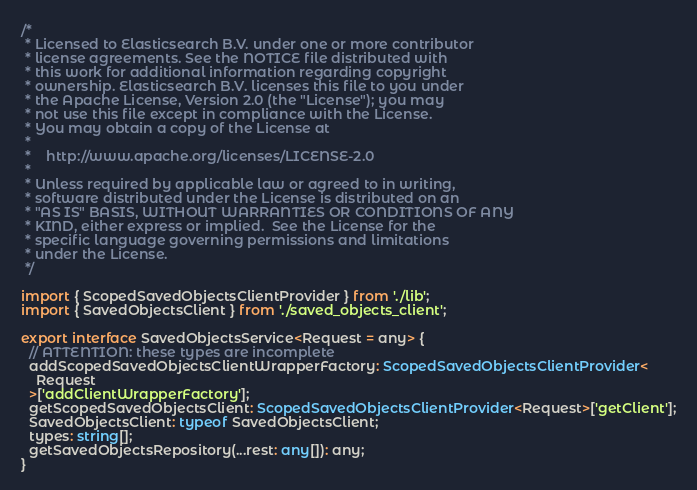Convert code to text. <code><loc_0><loc_0><loc_500><loc_500><_TypeScript_>/*
 * Licensed to Elasticsearch B.V. under one or more contributor
 * license agreements. See the NOTICE file distributed with
 * this work for additional information regarding copyright
 * ownership. Elasticsearch B.V. licenses this file to you under
 * the Apache License, Version 2.0 (the "License"); you may
 * not use this file except in compliance with the License.
 * You may obtain a copy of the License at
 *
 *    http://www.apache.org/licenses/LICENSE-2.0
 *
 * Unless required by applicable law or agreed to in writing,
 * software distributed under the License is distributed on an
 * "AS IS" BASIS, WITHOUT WARRANTIES OR CONDITIONS OF ANY
 * KIND, either express or implied.  See the License for the
 * specific language governing permissions and limitations
 * under the License.
 */

import { ScopedSavedObjectsClientProvider } from './lib';
import { SavedObjectsClient } from './saved_objects_client';

export interface SavedObjectsService<Request = any> {
  // ATTENTION: these types are incomplete
  addScopedSavedObjectsClientWrapperFactory: ScopedSavedObjectsClientProvider<
    Request
  >['addClientWrapperFactory'];
  getScopedSavedObjectsClient: ScopedSavedObjectsClientProvider<Request>['getClient'];
  SavedObjectsClient: typeof SavedObjectsClient;
  types: string[];
  getSavedObjectsRepository(...rest: any[]): any;
}
</code> 